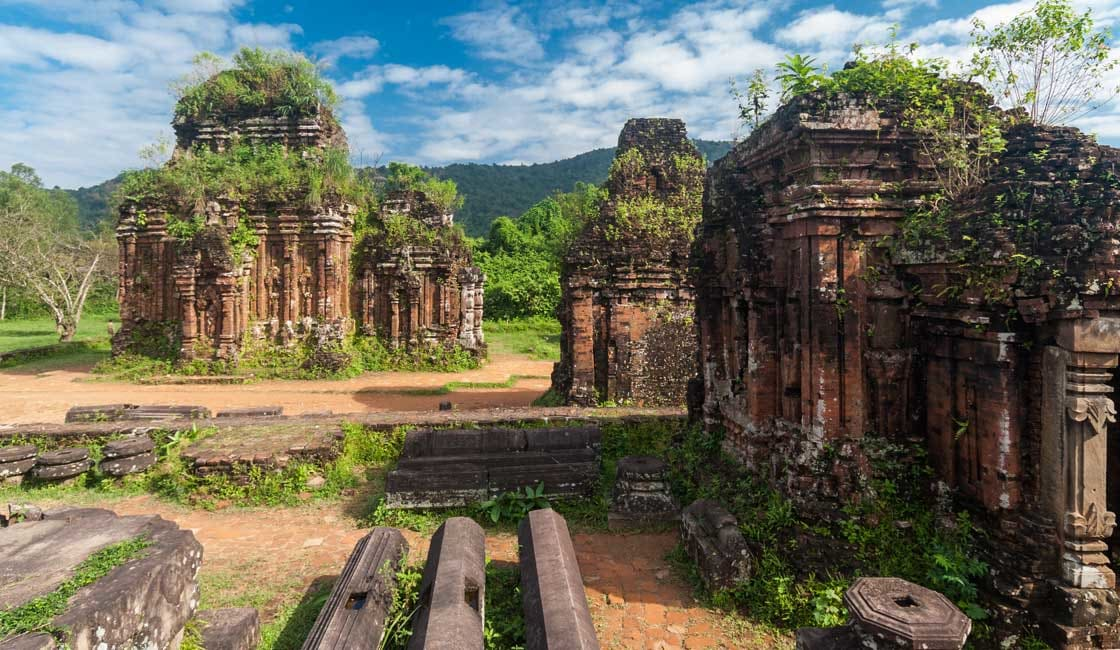What is this photo about'?
 This image captures the ancient beauty of the My Son temple complex in Vietnam. The scene is dominated by several brick temple structures, their once vibrant red now faded and worn with time. Despite their state of disrepair, the temples stand as a testament to the architectural prowess of the past. They are scattered across the image, some partially hidden by the lush greenery that surrounds them. The verdant vegetation adds a touch of life to the otherwise still image, its vibrant hues contrasting with the muted tones of the temples. In the distance, a mountain range stretches across the horizon, adding depth to the image. The perspective is from ground level, giving the viewer a sense of being in the midst of this historical site. The image is bathed in the soft light of day, highlighting the textures and details of the temple structures. This is a snapshot of a moment in time at the My Son temple complex, a place where history and nature coexist. 